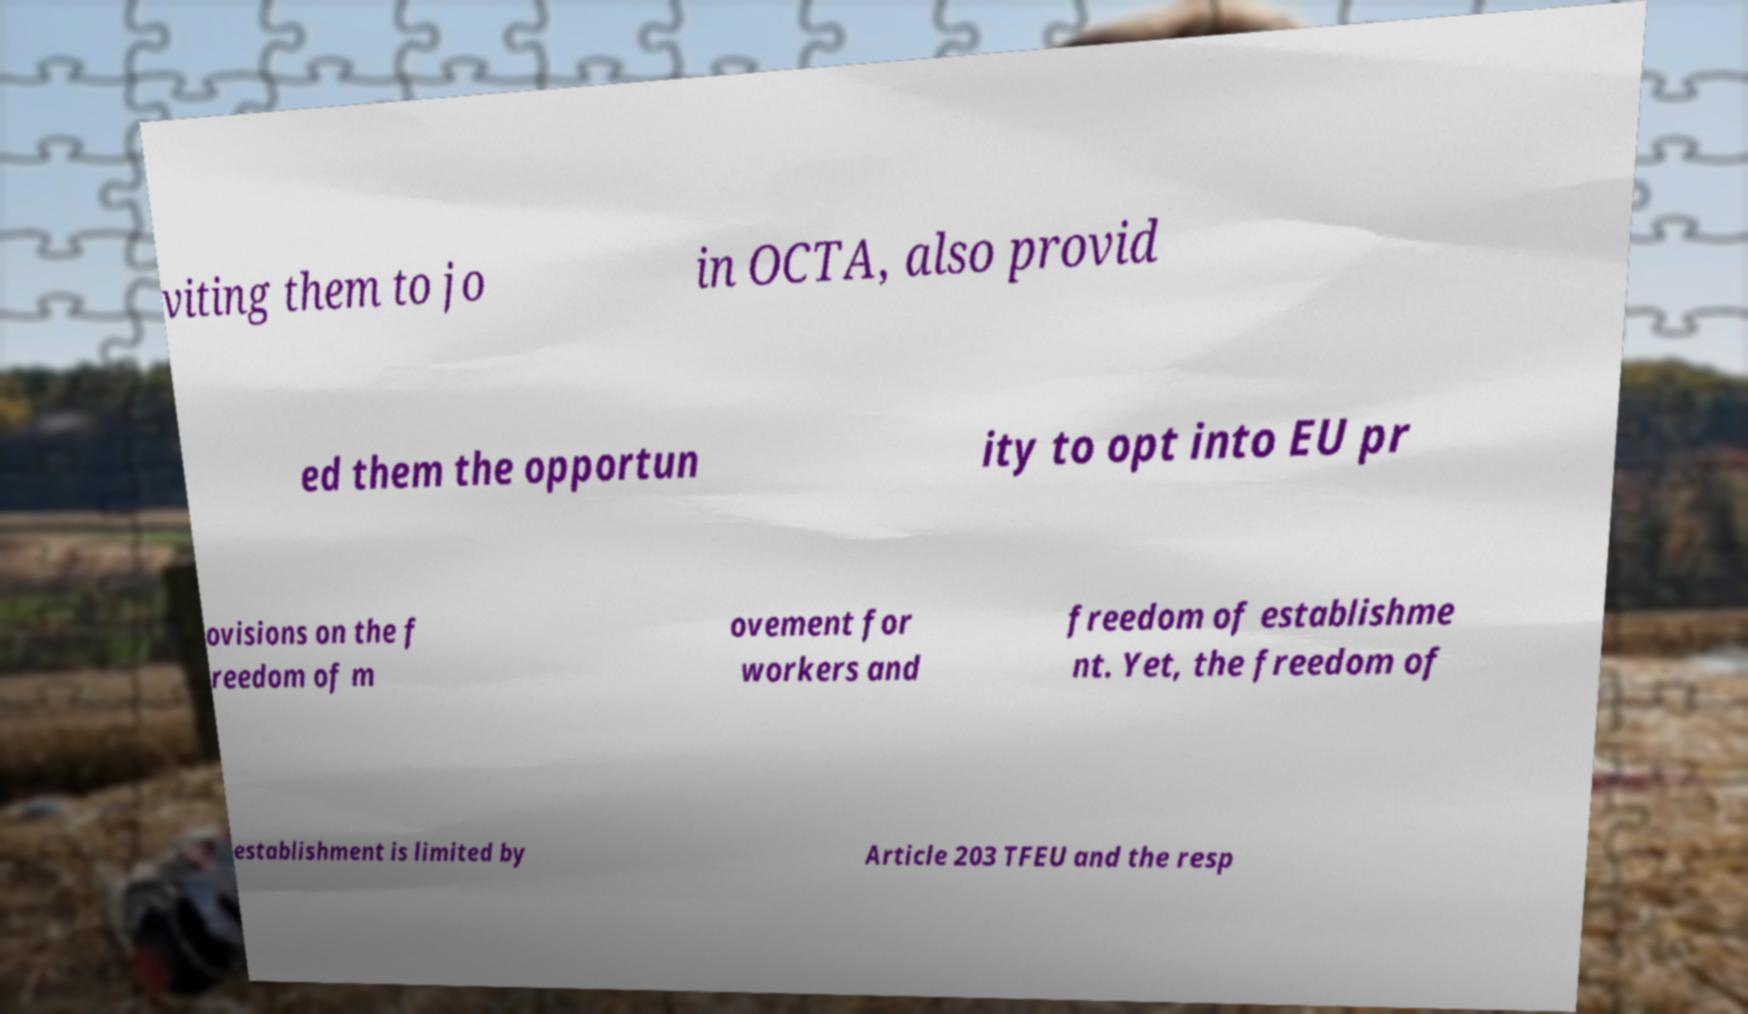Can you accurately transcribe the text from the provided image for me? viting them to jo in OCTA, also provid ed them the opportun ity to opt into EU pr ovisions on the f reedom of m ovement for workers and freedom of establishme nt. Yet, the freedom of establishment is limited by Article 203 TFEU and the resp 